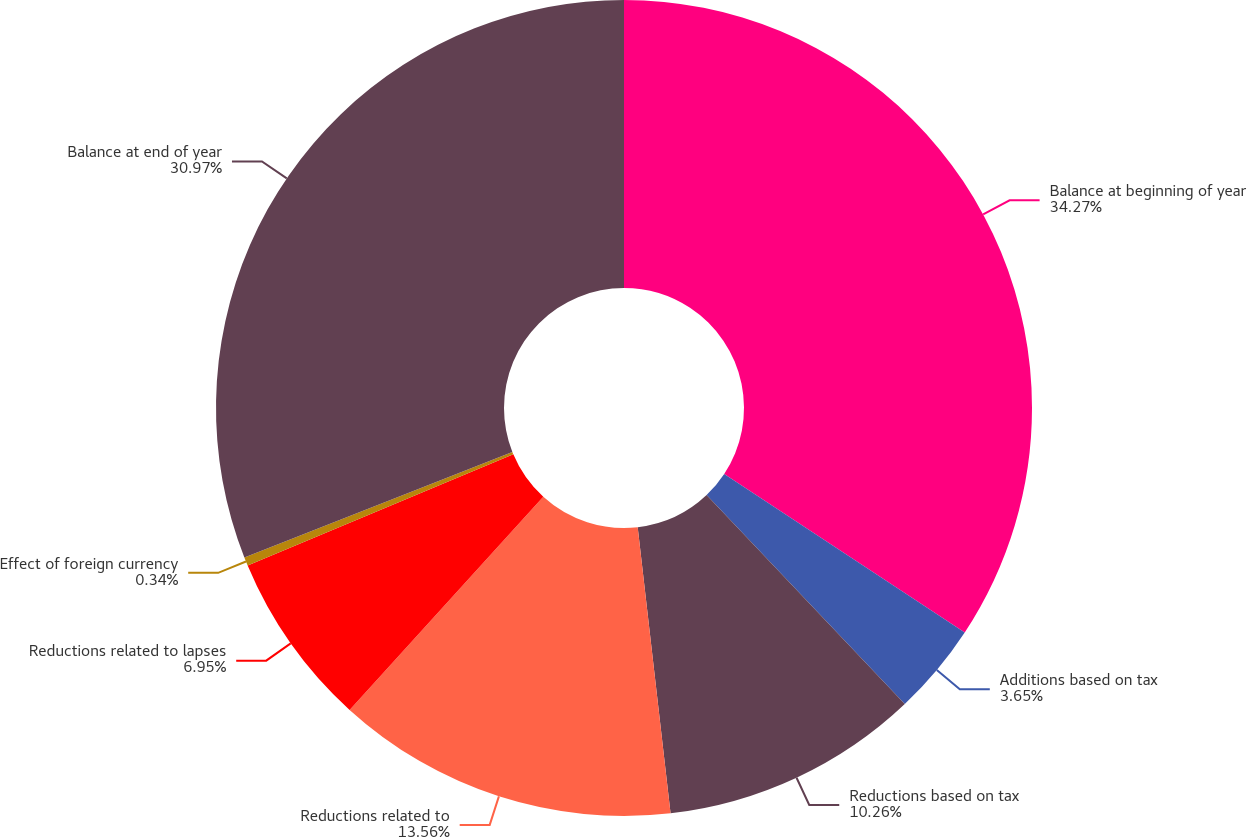Convert chart. <chart><loc_0><loc_0><loc_500><loc_500><pie_chart><fcel>Balance at beginning of year<fcel>Additions based on tax<fcel>Reductions based on tax<fcel>Reductions related to<fcel>Reductions related to lapses<fcel>Effect of foreign currency<fcel>Balance at end of year<nl><fcel>34.27%<fcel>3.65%<fcel>10.26%<fcel>13.56%<fcel>6.95%<fcel>0.34%<fcel>30.97%<nl></chart> 